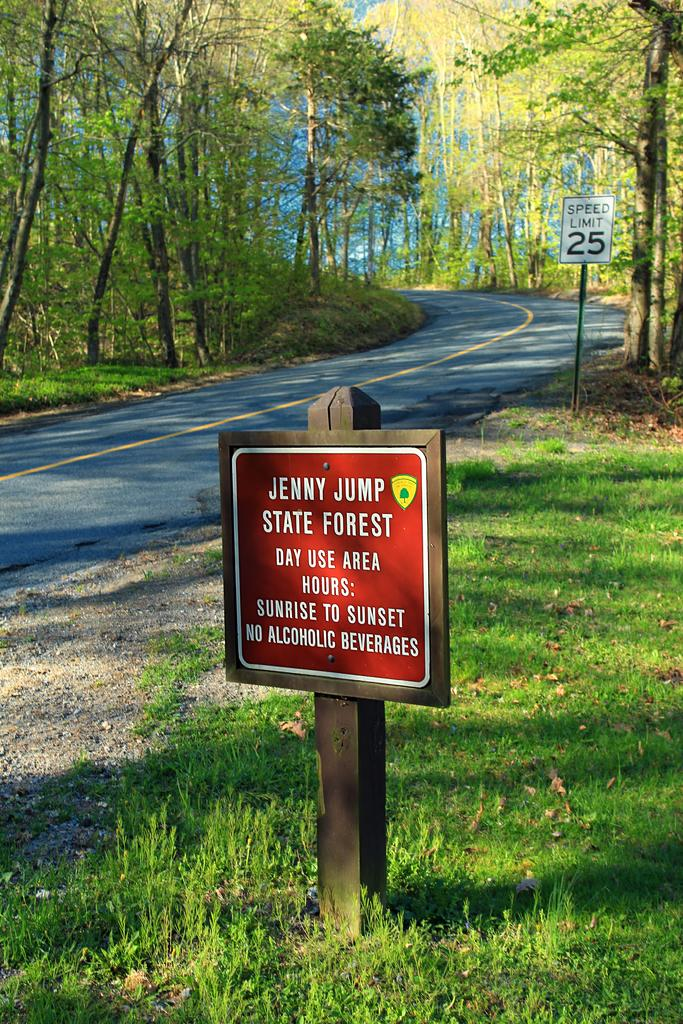What can be seen on the sign boards in the image? There are sign boards with text in the image. What type of natural environment is visible in the image? There is grass visible in the image. What type of man-made structure can be seen in the image? There is a road in the image. What type of vegetation is present in the image? There is a group of trees in the image. Where is the school located in the image? There is no school present in the image. What type of performance is happening on the stage in the image? There is no stage present in the image. 